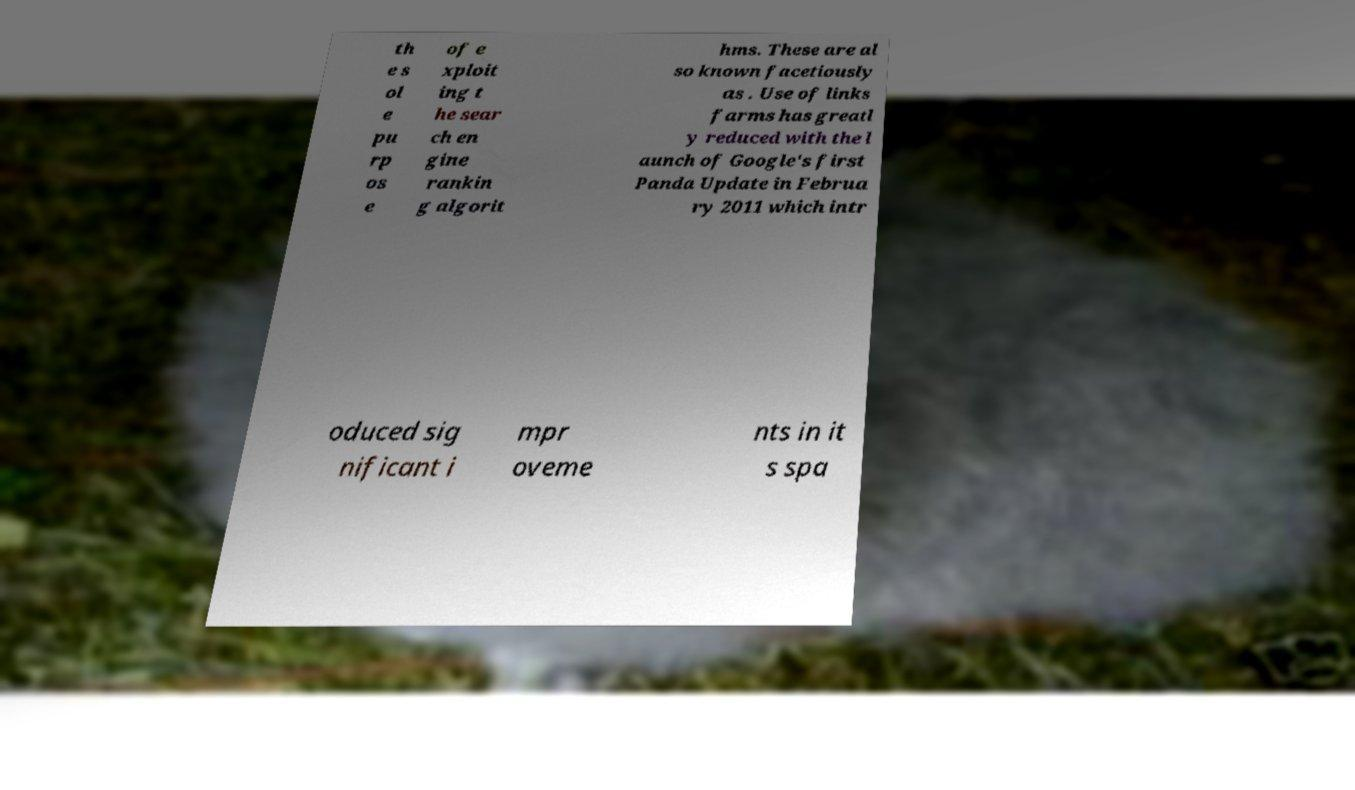Can you accurately transcribe the text from the provided image for me? th e s ol e pu rp os e of e xploit ing t he sear ch en gine rankin g algorit hms. These are al so known facetiously as . Use of links farms has greatl y reduced with the l aunch of Google's first Panda Update in Februa ry 2011 which intr oduced sig nificant i mpr oveme nts in it s spa 